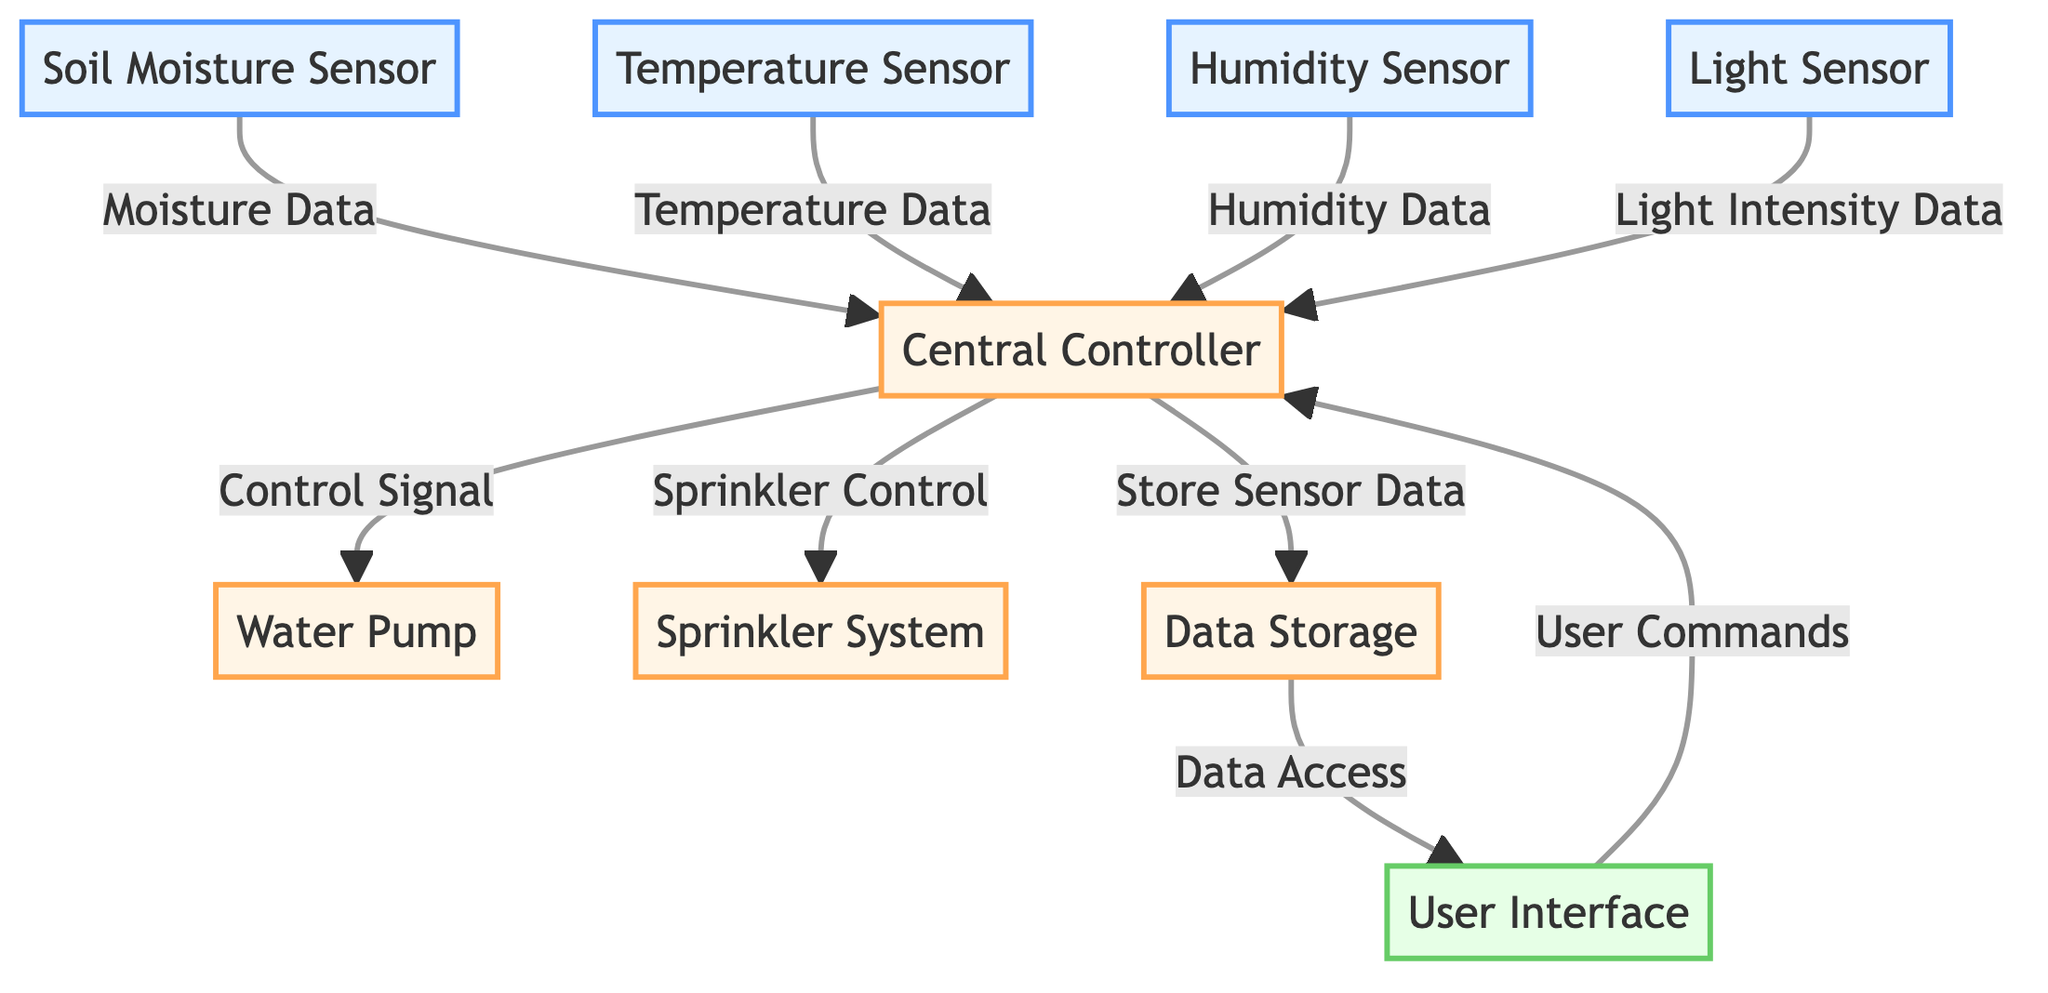What is the main controlling unit in the diagram? The diagram identifies the "Central Controller" as the main unit that coordinates data and signals between various sensors and devices.
Answer: Central Controller How many types of sensors are shown in the diagram? There are four distinct types of sensors labeled in the diagram: Soil Moisture Sensor, Temperature Sensor, Humidity Sensor, and Light Sensor.
Answer: Four What type of data does the Soil Moisture Sensor provide? The Soil Moisture Sensor sends "Moisture Data" to the Central Controller, which is used for irrigation decisions.
Answer: Moisture Data Which device receives control signals from the Central Controller? The Water Pump and the Sprinkler System both receive control signals from the Central Controller, allowing for automated irrigation.
Answer: Water Pump, Sprinkler System What is the purpose of the User Interface in the diagram? The User Interface allows users to input commands to the Central Controller and access data stored, facilitating user interaction with the system.
Answer: User Commands What is the flow of data from the sensors to the Central Controller? The data flow starts with four sensors (Soil Moisture, Temperature, Humidity, Light), which send their corresponding data types to the Central Controller, influencing the irrigation control.
Answer: Sensor Data to Central Controller How many total devices are present in the diagram? There are four devices shown in the diagram: Central Controller, Water Pump, Sprinkler System, and Data Storage.
Answer: Four Which component is responsible for storing sensor data? Data Storage receives and retains sensory information for later access through the User Interface in the system.
Answer: Data Storage What two control actions does the Central Controller perform? The Central Controller issues control signals to the Water Pump and Sprinkler System to manage irrigation based on sensory data.
Answer: Control Signals to Water Pump, Sprinkler System 